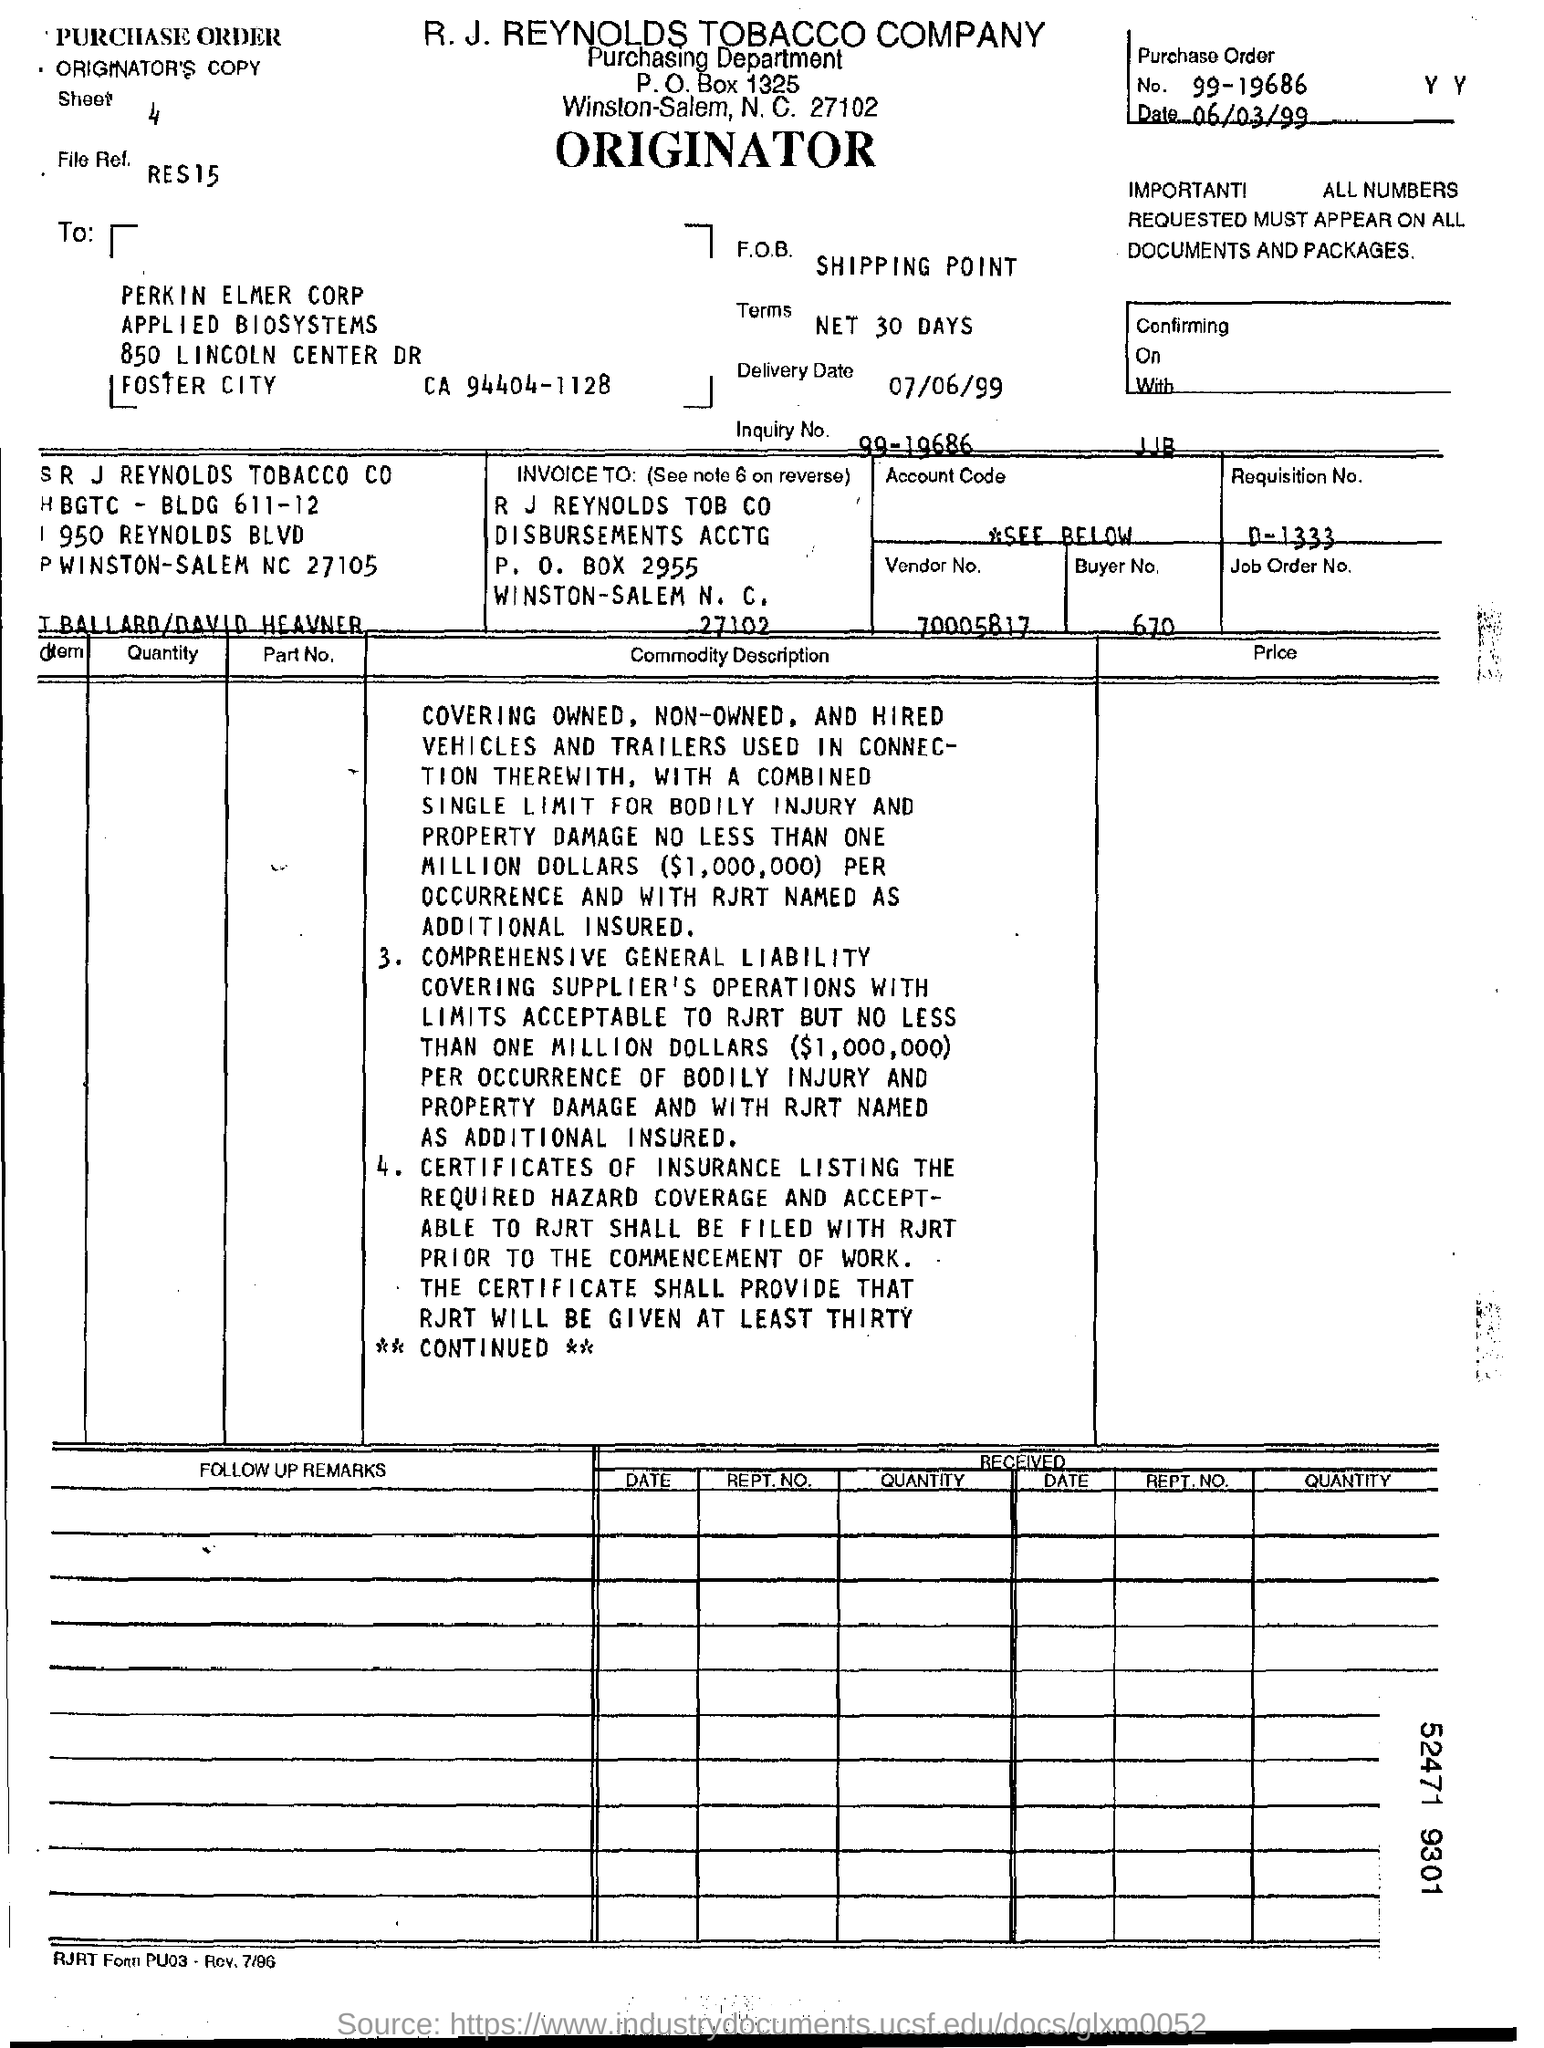Point out several critical features in this image. The date is June 3, 1999. A purchase order number is 99-19686. The requisition number is D-1333. The vendor number is 70005817. The buyer number is 670. 